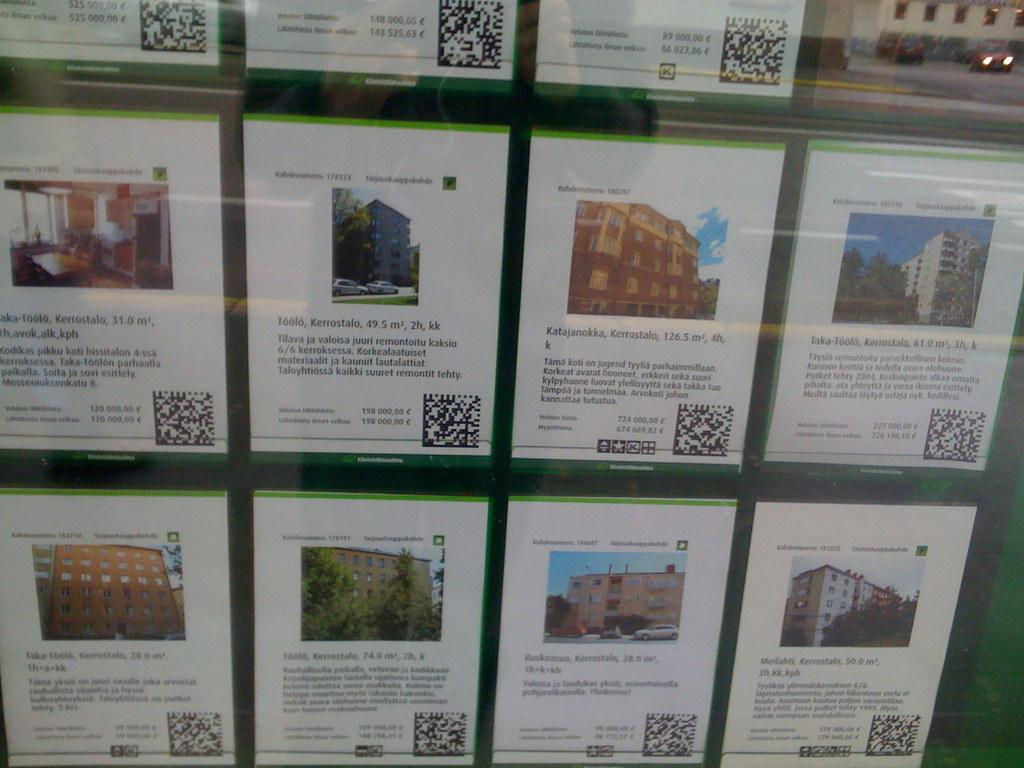<image>
Give a short and clear explanation of the subsequent image. Buildings for rent in Kerrostalo are displayed on papers. 